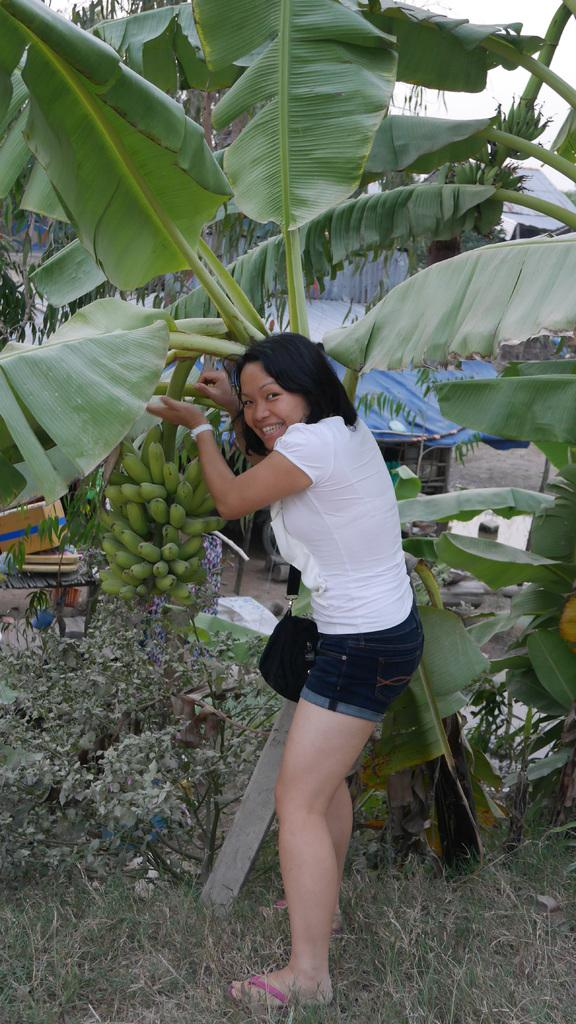What is the main subject of the image? There is a woman standing in the image. What is the ground made of in the image? The ground in the image is covered with grass and plants. Can you describe any specific features of the plants in the image? There is a tree with bananas in the image. How does the faucet affect the bananas on the tree in the image? There is no faucet present in the image, so it cannot affect the bananas on the tree. What season is depicted in the image? The provided facts do not mention any specific season, so it cannot be determined from the image. 